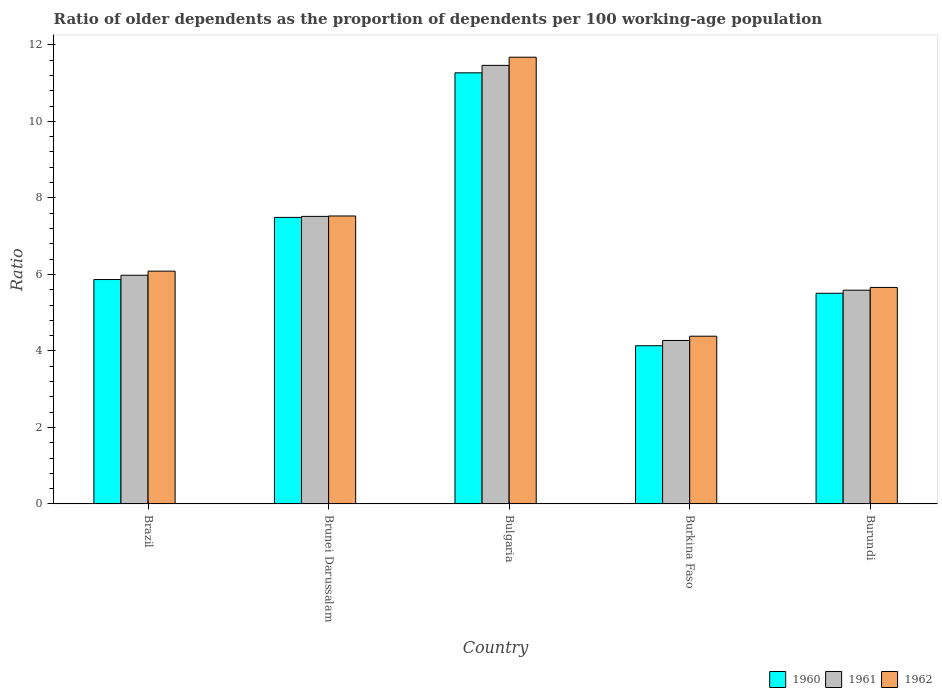How many different coloured bars are there?
Ensure brevity in your answer.  3. Are the number of bars per tick equal to the number of legend labels?
Your response must be concise. Yes. How many bars are there on the 2nd tick from the right?
Provide a short and direct response. 3. What is the label of the 1st group of bars from the left?
Your response must be concise. Brazil. In how many cases, is the number of bars for a given country not equal to the number of legend labels?
Your answer should be compact. 0. What is the age dependency ratio(old) in 1961 in Burkina Faso?
Offer a terse response. 4.27. Across all countries, what is the maximum age dependency ratio(old) in 1961?
Keep it short and to the point. 11.46. Across all countries, what is the minimum age dependency ratio(old) in 1962?
Give a very brief answer. 4.39. In which country was the age dependency ratio(old) in 1961 minimum?
Provide a short and direct response. Burkina Faso. What is the total age dependency ratio(old) in 1961 in the graph?
Provide a short and direct response. 34.82. What is the difference between the age dependency ratio(old) in 1961 in Brunei Darussalam and that in Bulgaria?
Offer a very short reply. -3.95. What is the difference between the age dependency ratio(old) in 1962 in Burundi and the age dependency ratio(old) in 1961 in Brunei Darussalam?
Provide a short and direct response. -1.86. What is the average age dependency ratio(old) in 1960 per country?
Ensure brevity in your answer.  6.85. What is the difference between the age dependency ratio(old) of/in 1962 and age dependency ratio(old) of/in 1961 in Burundi?
Make the answer very short. 0.07. In how many countries, is the age dependency ratio(old) in 1961 greater than 5.6?
Provide a short and direct response. 3. What is the ratio of the age dependency ratio(old) in 1960 in Bulgaria to that in Burundi?
Your answer should be compact. 2.05. What is the difference between the highest and the second highest age dependency ratio(old) in 1961?
Your answer should be very brief. 5.49. What is the difference between the highest and the lowest age dependency ratio(old) in 1961?
Your response must be concise. 7.19. In how many countries, is the age dependency ratio(old) in 1961 greater than the average age dependency ratio(old) in 1961 taken over all countries?
Provide a short and direct response. 2. What does the 3rd bar from the right in Bulgaria represents?
Ensure brevity in your answer.  1960. Is it the case that in every country, the sum of the age dependency ratio(old) in 1960 and age dependency ratio(old) in 1962 is greater than the age dependency ratio(old) in 1961?
Give a very brief answer. Yes. How many bars are there?
Provide a short and direct response. 15. Are the values on the major ticks of Y-axis written in scientific E-notation?
Keep it short and to the point. No. Does the graph contain grids?
Provide a succinct answer. No. How many legend labels are there?
Your answer should be compact. 3. What is the title of the graph?
Provide a succinct answer. Ratio of older dependents as the proportion of dependents per 100 working-age population. Does "1970" appear as one of the legend labels in the graph?
Make the answer very short. No. What is the label or title of the Y-axis?
Offer a very short reply. Ratio. What is the Ratio of 1960 in Brazil?
Provide a short and direct response. 5.87. What is the Ratio in 1961 in Brazil?
Offer a very short reply. 5.98. What is the Ratio of 1962 in Brazil?
Provide a succinct answer. 6.09. What is the Ratio of 1960 in Brunei Darussalam?
Give a very brief answer. 7.49. What is the Ratio in 1961 in Brunei Darussalam?
Your answer should be compact. 7.52. What is the Ratio of 1962 in Brunei Darussalam?
Make the answer very short. 7.53. What is the Ratio of 1960 in Bulgaria?
Offer a terse response. 11.27. What is the Ratio of 1961 in Bulgaria?
Offer a terse response. 11.46. What is the Ratio in 1962 in Bulgaria?
Offer a very short reply. 11.68. What is the Ratio in 1960 in Burkina Faso?
Your answer should be very brief. 4.14. What is the Ratio of 1961 in Burkina Faso?
Your answer should be very brief. 4.27. What is the Ratio of 1962 in Burkina Faso?
Ensure brevity in your answer.  4.39. What is the Ratio of 1960 in Burundi?
Your answer should be compact. 5.51. What is the Ratio in 1961 in Burundi?
Offer a terse response. 5.59. What is the Ratio of 1962 in Burundi?
Offer a very short reply. 5.66. Across all countries, what is the maximum Ratio in 1960?
Your answer should be very brief. 11.27. Across all countries, what is the maximum Ratio of 1961?
Offer a very short reply. 11.46. Across all countries, what is the maximum Ratio of 1962?
Provide a short and direct response. 11.68. Across all countries, what is the minimum Ratio of 1960?
Offer a terse response. 4.14. Across all countries, what is the minimum Ratio in 1961?
Provide a succinct answer. 4.27. Across all countries, what is the minimum Ratio of 1962?
Make the answer very short. 4.39. What is the total Ratio in 1960 in the graph?
Ensure brevity in your answer.  34.27. What is the total Ratio of 1961 in the graph?
Your response must be concise. 34.82. What is the total Ratio in 1962 in the graph?
Ensure brevity in your answer.  35.33. What is the difference between the Ratio of 1960 in Brazil and that in Brunei Darussalam?
Your answer should be compact. -1.62. What is the difference between the Ratio of 1961 in Brazil and that in Brunei Darussalam?
Provide a short and direct response. -1.54. What is the difference between the Ratio in 1962 in Brazil and that in Brunei Darussalam?
Provide a succinct answer. -1.44. What is the difference between the Ratio of 1960 in Brazil and that in Bulgaria?
Offer a very short reply. -5.4. What is the difference between the Ratio in 1961 in Brazil and that in Bulgaria?
Keep it short and to the point. -5.49. What is the difference between the Ratio of 1962 in Brazil and that in Bulgaria?
Your answer should be very brief. -5.59. What is the difference between the Ratio in 1960 in Brazil and that in Burkina Faso?
Keep it short and to the point. 1.73. What is the difference between the Ratio of 1961 in Brazil and that in Burkina Faso?
Give a very brief answer. 1.71. What is the difference between the Ratio of 1962 in Brazil and that in Burkina Faso?
Keep it short and to the point. 1.7. What is the difference between the Ratio of 1960 in Brazil and that in Burundi?
Your response must be concise. 0.36. What is the difference between the Ratio in 1961 in Brazil and that in Burundi?
Your answer should be compact. 0.39. What is the difference between the Ratio of 1962 in Brazil and that in Burundi?
Ensure brevity in your answer.  0.43. What is the difference between the Ratio in 1960 in Brunei Darussalam and that in Bulgaria?
Ensure brevity in your answer.  -3.78. What is the difference between the Ratio in 1961 in Brunei Darussalam and that in Bulgaria?
Keep it short and to the point. -3.95. What is the difference between the Ratio of 1962 in Brunei Darussalam and that in Bulgaria?
Make the answer very short. -4.15. What is the difference between the Ratio of 1960 in Brunei Darussalam and that in Burkina Faso?
Provide a succinct answer. 3.35. What is the difference between the Ratio of 1961 in Brunei Darussalam and that in Burkina Faso?
Give a very brief answer. 3.24. What is the difference between the Ratio of 1962 in Brunei Darussalam and that in Burkina Faso?
Your response must be concise. 3.14. What is the difference between the Ratio of 1960 in Brunei Darussalam and that in Burundi?
Provide a short and direct response. 1.98. What is the difference between the Ratio in 1961 in Brunei Darussalam and that in Burundi?
Provide a short and direct response. 1.93. What is the difference between the Ratio of 1962 in Brunei Darussalam and that in Burundi?
Offer a very short reply. 1.87. What is the difference between the Ratio in 1960 in Bulgaria and that in Burkina Faso?
Your answer should be very brief. 7.13. What is the difference between the Ratio of 1961 in Bulgaria and that in Burkina Faso?
Give a very brief answer. 7.19. What is the difference between the Ratio in 1962 in Bulgaria and that in Burkina Faso?
Keep it short and to the point. 7.29. What is the difference between the Ratio in 1960 in Bulgaria and that in Burundi?
Keep it short and to the point. 5.76. What is the difference between the Ratio in 1961 in Bulgaria and that in Burundi?
Provide a succinct answer. 5.88. What is the difference between the Ratio in 1962 in Bulgaria and that in Burundi?
Provide a succinct answer. 6.02. What is the difference between the Ratio of 1960 in Burkina Faso and that in Burundi?
Offer a very short reply. -1.37. What is the difference between the Ratio of 1961 in Burkina Faso and that in Burundi?
Your response must be concise. -1.31. What is the difference between the Ratio in 1962 in Burkina Faso and that in Burundi?
Your answer should be compact. -1.27. What is the difference between the Ratio of 1960 in Brazil and the Ratio of 1961 in Brunei Darussalam?
Provide a succinct answer. -1.65. What is the difference between the Ratio in 1960 in Brazil and the Ratio in 1962 in Brunei Darussalam?
Make the answer very short. -1.66. What is the difference between the Ratio in 1961 in Brazil and the Ratio in 1962 in Brunei Darussalam?
Provide a short and direct response. -1.55. What is the difference between the Ratio of 1960 in Brazil and the Ratio of 1961 in Bulgaria?
Offer a very short reply. -5.6. What is the difference between the Ratio of 1960 in Brazil and the Ratio of 1962 in Bulgaria?
Provide a short and direct response. -5.81. What is the difference between the Ratio in 1961 in Brazil and the Ratio in 1962 in Bulgaria?
Offer a terse response. -5.7. What is the difference between the Ratio in 1960 in Brazil and the Ratio in 1961 in Burkina Faso?
Offer a very short reply. 1.59. What is the difference between the Ratio in 1960 in Brazil and the Ratio in 1962 in Burkina Faso?
Give a very brief answer. 1.48. What is the difference between the Ratio in 1961 in Brazil and the Ratio in 1962 in Burkina Faso?
Offer a terse response. 1.59. What is the difference between the Ratio in 1960 in Brazil and the Ratio in 1961 in Burundi?
Your answer should be very brief. 0.28. What is the difference between the Ratio of 1960 in Brazil and the Ratio of 1962 in Burundi?
Provide a short and direct response. 0.21. What is the difference between the Ratio in 1961 in Brazil and the Ratio in 1962 in Burundi?
Make the answer very short. 0.32. What is the difference between the Ratio in 1960 in Brunei Darussalam and the Ratio in 1961 in Bulgaria?
Your answer should be very brief. -3.97. What is the difference between the Ratio in 1960 in Brunei Darussalam and the Ratio in 1962 in Bulgaria?
Provide a short and direct response. -4.19. What is the difference between the Ratio of 1961 in Brunei Darussalam and the Ratio of 1962 in Bulgaria?
Offer a very short reply. -4.16. What is the difference between the Ratio of 1960 in Brunei Darussalam and the Ratio of 1961 in Burkina Faso?
Ensure brevity in your answer.  3.22. What is the difference between the Ratio in 1960 in Brunei Darussalam and the Ratio in 1962 in Burkina Faso?
Make the answer very short. 3.1. What is the difference between the Ratio in 1961 in Brunei Darussalam and the Ratio in 1962 in Burkina Faso?
Your response must be concise. 3.13. What is the difference between the Ratio of 1960 in Brunei Darussalam and the Ratio of 1961 in Burundi?
Offer a terse response. 1.9. What is the difference between the Ratio of 1960 in Brunei Darussalam and the Ratio of 1962 in Burundi?
Offer a terse response. 1.83. What is the difference between the Ratio in 1961 in Brunei Darussalam and the Ratio in 1962 in Burundi?
Your answer should be very brief. 1.86. What is the difference between the Ratio of 1960 in Bulgaria and the Ratio of 1961 in Burkina Faso?
Your response must be concise. 7. What is the difference between the Ratio in 1960 in Bulgaria and the Ratio in 1962 in Burkina Faso?
Offer a terse response. 6.88. What is the difference between the Ratio in 1961 in Bulgaria and the Ratio in 1962 in Burkina Faso?
Ensure brevity in your answer.  7.08. What is the difference between the Ratio in 1960 in Bulgaria and the Ratio in 1961 in Burundi?
Provide a short and direct response. 5.68. What is the difference between the Ratio in 1960 in Bulgaria and the Ratio in 1962 in Burundi?
Offer a terse response. 5.61. What is the difference between the Ratio of 1961 in Bulgaria and the Ratio of 1962 in Burundi?
Ensure brevity in your answer.  5.8. What is the difference between the Ratio in 1960 in Burkina Faso and the Ratio in 1961 in Burundi?
Your answer should be very brief. -1.45. What is the difference between the Ratio of 1960 in Burkina Faso and the Ratio of 1962 in Burundi?
Give a very brief answer. -1.52. What is the difference between the Ratio of 1961 in Burkina Faso and the Ratio of 1962 in Burundi?
Provide a succinct answer. -1.39. What is the average Ratio in 1960 per country?
Your answer should be very brief. 6.85. What is the average Ratio in 1961 per country?
Your answer should be very brief. 6.96. What is the average Ratio in 1962 per country?
Provide a succinct answer. 7.07. What is the difference between the Ratio of 1960 and Ratio of 1961 in Brazil?
Keep it short and to the point. -0.11. What is the difference between the Ratio of 1960 and Ratio of 1962 in Brazil?
Provide a short and direct response. -0.22. What is the difference between the Ratio of 1961 and Ratio of 1962 in Brazil?
Give a very brief answer. -0.11. What is the difference between the Ratio of 1960 and Ratio of 1961 in Brunei Darussalam?
Ensure brevity in your answer.  -0.03. What is the difference between the Ratio in 1960 and Ratio in 1962 in Brunei Darussalam?
Make the answer very short. -0.04. What is the difference between the Ratio of 1961 and Ratio of 1962 in Brunei Darussalam?
Your answer should be very brief. -0.01. What is the difference between the Ratio in 1960 and Ratio in 1961 in Bulgaria?
Ensure brevity in your answer.  -0.2. What is the difference between the Ratio of 1960 and Ratio of 1962 in Bulgaria?
Your response must be concise. -0.41. What is the difference between the Ratio of 1961 and Ratio of 1962 in Bulgaria?
Make the answer very short. -0.21. What is the difference between the Ratio in 1960 and Ratio in 1961 in Burkina Faso?
Provide a short and direct response. -0.14. What is the difference between the Ratio of 1960 and Ratio of 1962 in Burkina Faso?
Ensure brevity in your answer.  -0.25. What is the difference between the Ratio in 1961 and Ratio in 1962 in Burkina Faso?
Ensure brevity in your answer.  -0.11. What is the difference between the Ratio in 1960 and Ratio in 1961 in Burundi?
Your answer should be very brief. -0.08. What is the difference between the Ratio in 1960 and Ratio in 1962 in Burundi?
Your response must be concise. -0.15. What is the difference between the Ratio of 1961 and Ratio of 1962 in Burundi?
Offer a terse response. -0.07. What is the ratio of the Ratio in 1960 in Brazil to that in Brunei Darussalam?
Give a very brief answer. 0.78. What is the ratio of the Ratio in 1961 in Brazil to that in Brunei Darussalam?
Offer a terse response. 0.8. What is the ratio of the Ratio of 1962 in Brazil to that in Brunei Darussalam?
Ensure brevity in your answer.  0.81. What is the ratio of the Ratio of 1960 in Brazil to that in Bulgaria?
Offer a terse response. 0.52. What is the ratio of the Ratio of 1961 in Brazil to that in Bulgaria?
Make the answer very short. 0.52. What is the ratio of the Ratio in 1962 in Brazil to that in Bulgaria?
Your response must be concise. 0.52. What is the ratio of the Ratio in 1960 in Brazil to that in Burkina Faso?
Ensure brevity in your answer.  1.42. What is the ratio of the Ratio in 1961 in Brazil to that in Burkina Faso?
Your answer should be very brief. 1.4. What is the ratio of the Ratio in 1962 in Brazil to that in Burkina Faso?
Offer a very short reply. 1.39. What is the ratio of the Ratio in 1960 in Brazil to that in Burundi?
Provide a succinct answer. 1.07. What is the ratio of the Ratio in 1961 in Brazil to that in Burundi?
Provide a short and direct response. 1.07. What is the ratio of the Ratio in 1962 in Brazil to that in Burundi?
Offer a very short reply. 1.08. What is the ratio of the Ratio in 1960 in Brunei Darussalam to that in Bulgaria?
Your answer should be compact. 0.66. What is the ratio of the Ratio of 1961 in Brunei Darussalam to that in Bulgaria?
Provide a short and direct response. 0.66. What is the ratio of the Ratio in 1962 in Brunei Darussalam to that in Bulgaria?
Provide a succinct answer. 0.64. What is the ratio of the Ratio of 1960 in Brunei Darussalam to that in Burkina Faso?
Provide a succinct answer. 1.81. What is the ratio of the Ratio of 1961 in Brunei Darussalam to that in Burkina Faso?
Offer a terse response. 1.76. What is the ratio of the Ratio of 1962 in Brunei Darussalam to that in Burkina Faso?
Your answer should be compact. 1.72. What is the ratio of the Ratio in 1960 in Brunei Darussalam to that in Burundi?
Offer a very short reply. 1.36. What is the ratio of the Ratio of 1961 in Brunei Darussalam to that in Burundi?
Your response must be concise. 1.35. What is the ratio of the Ratio in 1962 in Brunei Darussalam to that in Burundi?
Offer a terse response. 1.33. What is the ratio of the Ratio of 1960 in Bulgaria to that in Burkina Faso?
Offer a very short reply. 2.72. What is the ratio of the Ratio of 1961 in Bulgaria to that in Burkina Faso?
Your answer should be compact. 2.68. What is the ratio of the Ratio of 1962 in Bulgaria to that in Burkina Faso?
Make the answer very short. 2.66. What is the ratio of the Ratio in 1960 in Bulgaria to that in Burundi?
Keep it short and to the point. 2.05. What is the ratio of the Ratio in 1961 in Bulgaria to that in Burundi?
Give a very brief answer. 2.05. What is the ratio of the Ratio of 1962 in Bulgaria to that in Burundi?
Provide a succinct answer. 2.06. What is the ratio of the Ratio of 1960 in Burkina Faso to that in Burundi?
Ensure brevity in your answer.  0.75. What is the ratio of the Ratio of 1961 in Burkina Faso to that in Burundi?
Make the answer very short. 0.76. What is the ratio of the Ratio of 1962 in Burkina Faso to that in Burundi?
Make the answer very short. 0.77. What is the difference between the highest and the second highest Ratio in 1960?
Offer a very short reply. 3.78. What is the difference between the highest and the second highest Ratio of 1961?
Your answer should be very brief. 3.95. What is the difference between the highest and the second highest Ratio of 1962?
Give a very brief answer. 4.15. What is the difference between the highest and the lowest Ratio in 1960?
Your response must be concise. 7.13. What is the difference between the highest and the lowest Ratio in 1961?
Give a very brief answer. 7.19. What is the difference between the highest and the lowest Ratio in 1962?
Offer a terse response. 7.29. 